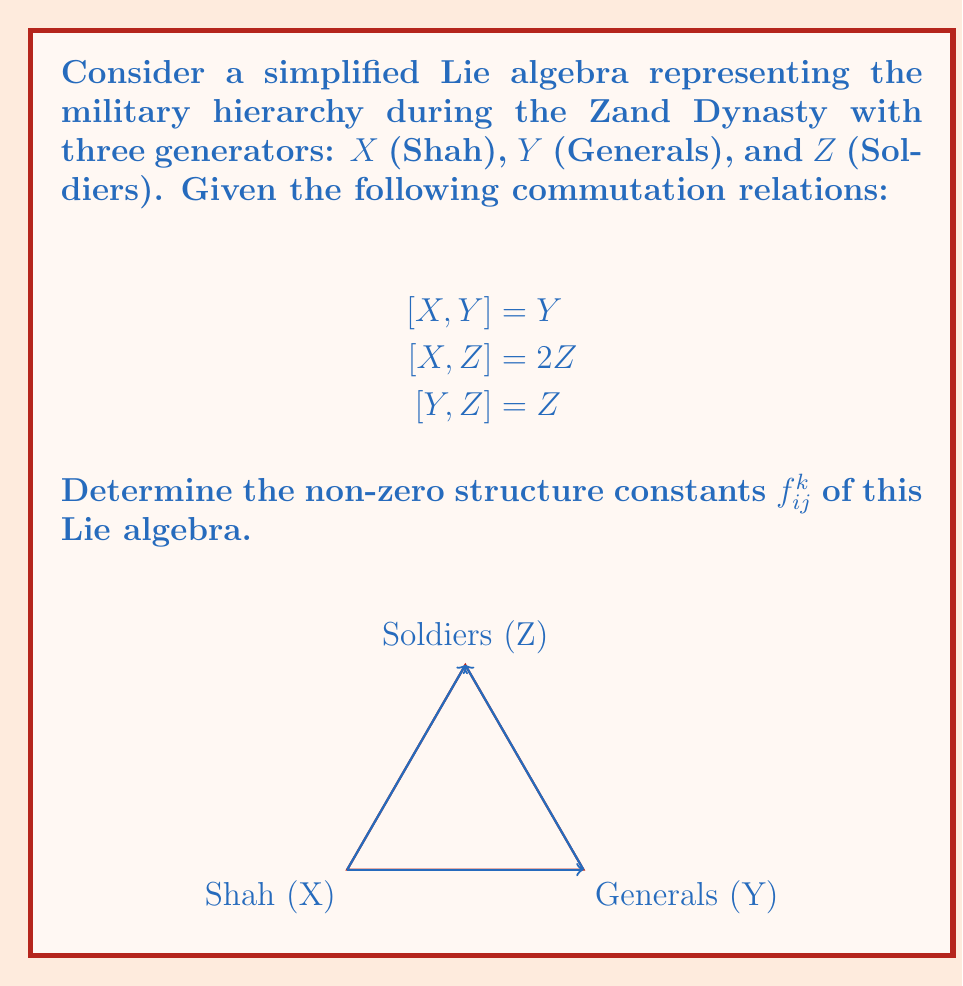What is the answer to this math problem? To determine the structure constants, we follow these steps:

1) The structure constants $f_{ij}^k$ are defined by the commutation relations:

   $$[X_i, X_j] = \sum_k f_{ij}^k X_k$$

2) From the given commutation relations, we can identify:

   $$[X,Y] = Y \implies f_{XY}^Y = 1$$
   $$[X,Z] = 2Z \implies f_{XZ}^Z = 2$$
   $$[Y,Z] = Z \implies f_{YZ}^Z = 1$$

3) Note that $f_{ij}^k = -f_{ji}^k$ due to the antisymmetry of the commutator. So:

   $$f_{YX}^Y = -1$$
   $$f_{ZX}^Z = -2$$
   $$f_{ZY}^Z = -1$$

4) All other structure constants are zero.

5) We can represent these in a compact form as:

   $$f_{XY}^Y = -f_{YX}^Y = 1$$
   $$f_{XZ}^Z = -f_{ZX}^Z = 2$$
   $$f_{YZ}^Z = -f_{ZY}^Z = 1$$
Answer: $f_{XY}^Y = 1, f_{XZ}^Z = 2, f_{YZ}^Z = 1, f_{YX}^Y = -1, f_{ZX}^Z = -2, f_{ZY}^Z = -1$ 